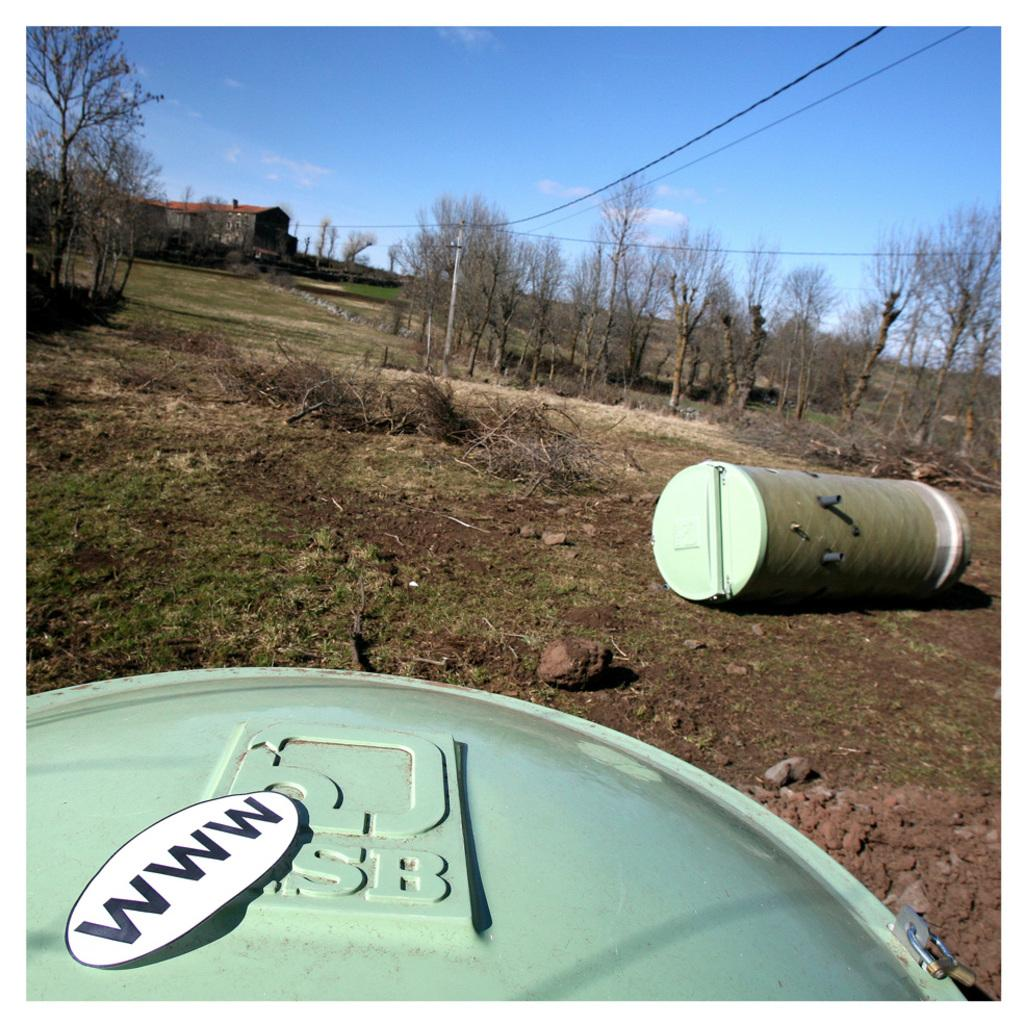How many barrels are in the image? There are two barrels in the image. What other objects can be seen in the image? There are rocks, mud, plants, trees, a house, and wires visible in the image. What type of vegetation is present in the image? There are plants and trees in the image. What is the background of the image? The sky is visible in the image. Can you see your brother's chin in the image? There is no reference to a brother or a chin in the image, so it is not possible to answer that question. 